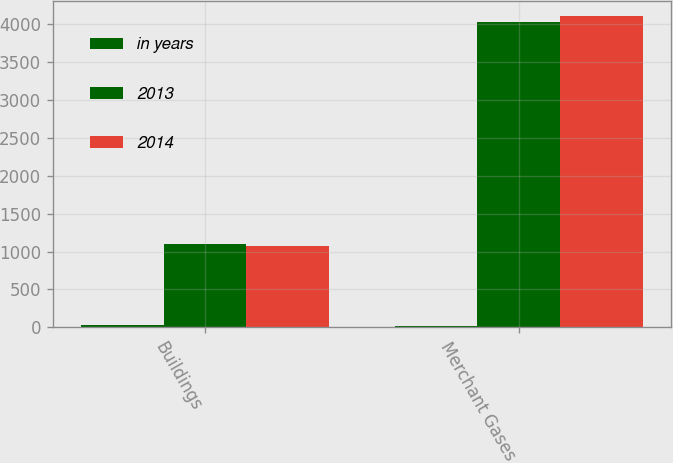Convert chart. <chart><loc_0><loc_0><loc_500><loc_500><stacked_bar_chart><ecel><fcel>Buildings<fcel>Merchant Gases<nl><fcel>in years<fcel>30<fcel>15<nl><fcel>2013<fcel>1105<fcel>4034.4<nl><fcel>2014<fcel>1076.3<fcel>4109.1<nl></chart> 